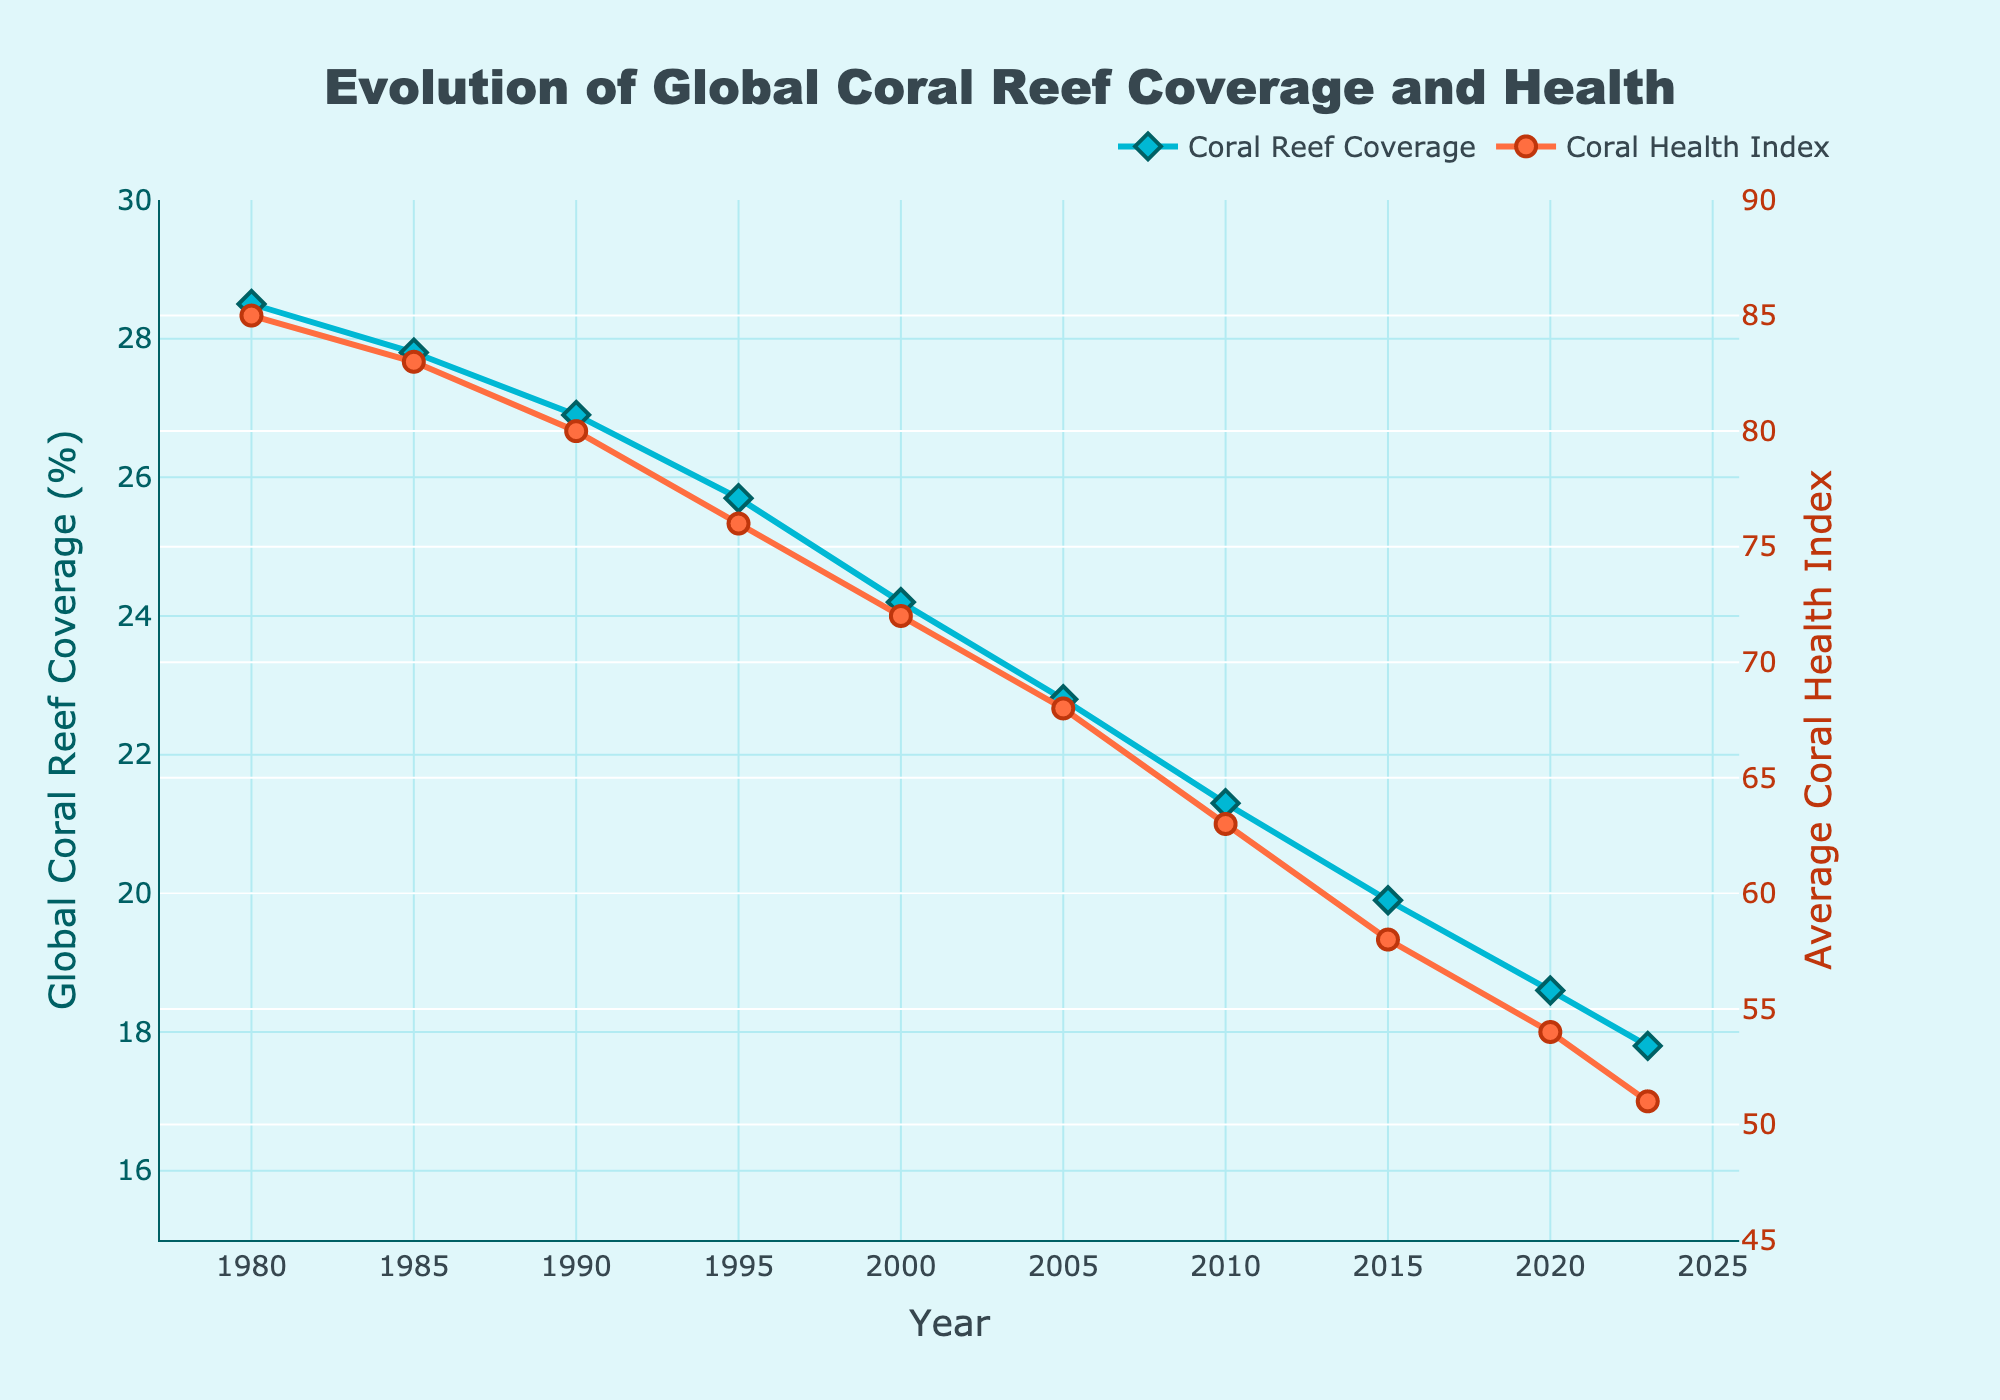How has global coral reef coverage changed from 1980 to 2023? The global coral reef coverage has been shown to decrease linearly from 28.5% in 1980 to 17.8% in 2023 according to the blue line on the chart.
Answer: Decreased from 28.5% to 17.8% Compare the coral health index in 1980 with that in 2023. In 1980, the Average Coral Health Index was 85, while in 2023 it is 51, as shown by the red line. Therefore, the index dropped significantly from 1980 to 2023.
Answer: Dropped from 85 to 51 By how many percentage points has the global coral reef coverage decreased from 1980 to 2023? To find the change in coral reef coverage, subtract the value in 2023 from the value in 1980: 28.5 - 17.8 = 10.7 percentage points.
Answer: 10.7 percentage points What is the ratio of the Average Coral Health Index in 1980 to that in 2023? The Average Coral Health Index in 1980 is 85 and in 2023 is 51. The ratio is calculated as 85/51 ≈ 1.67.
Answer: 1.67 What is the overall trend in the Average Coral Health Index from 1980 to 2023? The trend of the Average Coral Health Index from 1980 to 2023, shown by the red line, is a consistent decline.
Answer: Decline By how much did the Average Coral Health Index decline between 2000 and 2023? Subtract the Index value in 2023 (51) from its value in 2000 (72): 72 - 51 = 21 points.
Answer: 21 points 